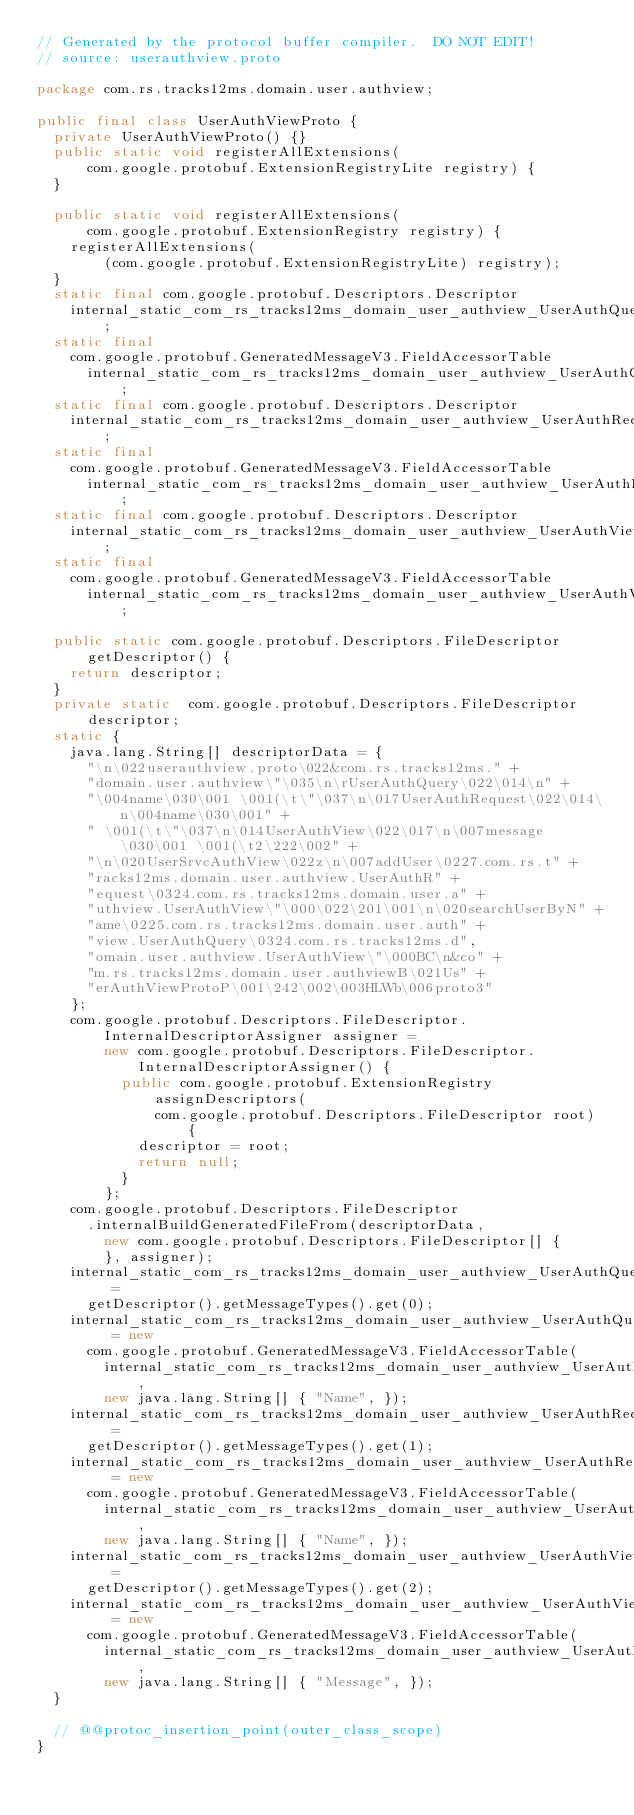<code> <loc_0><loc_0><loc_500><loc_500><_Java_>// Generated by the protocol buffer compiler.  DO NOT EDIT!
// source: userauthview.proto

package com.rs.tracks12ms.domain.user.authview;

public final class UserAuthViewProto {
  private UserAuthViewProto() {}
  public static void registerAllExtensions(
      com.google.protobuf.ExtensionRegistryLite registry) {
  }

  public static void registerAllExtensions(
      com.google.protobuf.ExtensionRegistry registry) {
    registerAllExtensions(
        (com.google.protobuf.ExtensionRegistryLite) registry);
  }
  static final com.google.protobuf.Descriptors.Descriptor
    internal_static_com_rs_tracks12ms_domain_user_authview_UserAuthQuery_descriptor;
  static final 
    com.google.protobuf.GeneratedMessageV3.FieldAccessorTable
      internal_static_com_rs_tracks12ms_domain_user_authview_UserAuthQuery_fieldAccessorTable;
  static final com.google.protobuf.Descriptors.Descriptor
    internal_static_com_rs_tracks12ms_domain_user_authview_UserAuthRequest_descriptor;
  static final 
    com.google.protobuf.GeneratedMessageV3.FieldAccessorTable
      internal_static_com_rs_tracks12ms_domain_user_authview_UserAuthRequest_fieldAccessorTable;
  static final com.google.protobuf.Descriptors.Descriptor
    internal_static_com_rs_tracks12ms_domain_user_authview_UserAuthView_descriptor;
  static final 
    com.google.protobuf.GeneratedMessageV3.FieldAccessorTable
      internal_static_com_rs_tracks12ms_domain_user_authview_UserAuthView_fieldAccessorTable;

  public static com.google.protobuf.Descriptors.FileDescriptor
      getDescriptor() {
    return descriptor;
  }
  private static  com.google.protobuf.Descriptors.FileDescriptor
      descriptor;
  static {
    java.lang.String[] descriptorData = {
      "\n\022userauthview.proto\022&com.rs.tracks12ms." +
      "domain.user.authview\"\035\n\rUserAuthQuery\022\014\n" +
      "\004name\030\001 \001(\t\"\037\n\017UserAuthRequest\022\014\n\004name\030\001" +
      " \001(\t\"\037\n\014UserAuthView\022\017\n\007message\030\001 \001(\t2\222\002" +
      "\n\020UserSrvcAuthView\022z\n\007addUser\0227.com.rs.t" +
      "racks12ms.domain.user.authview.UserAuthR" +
      "equest\0324.com.rs.tracks12ms.domain.user.a" +
      "uthview.UserAuthView\"\000\022\201\001\n\020searchUserByN" +
      "ame\0225.com.rs.tracks12ms.domain.user.auth" +
      "view.UserAuthQuery\0324.com.rs.tracks12ms.d",
      "omain.user.authview.UserAuthView\"\000BC\n&co" +
      "m.rs.tracks12ms.domain.user.authviewB\021Us" +
      "erAuthViewProtoP\001\242\002\003HLWb\006proto3"
    };
    com.google.protobuf.Descriptors.FileDescriptor.InternalDescriptorAssigner assigner =
        new com.google.protobuf.Descriptors.FileDescriptor.    InternalDescriptorAssigner() {
          public com.google.protobuf.ExtensionRegistry assignDescriptors(
              com.google.protobuf.Descriptors.FileDescriptor root) {
            descriptor = root;
            return null;
          }
        };
    com.google.protobuf.Descriptors.FileDescriptor
      .internalBuildGeneratedFileFrom(descriptorData,
        new com.google.protobuf.Descriptors.FileDescriptor[] {
        }, assigner);
    internal_static_com_rs_tracks12ms_domain_user_authview_UserAuthQuery_descriptor =
      getDescriptor().getMessageTypes().get(0);
    internal_static_com_rs_tracks12ms_domain_user_authview_UserAuthQuery_fieldAccessorTable = new
      com.google.protobuf.GeneratedMessageV3.FieldAccessorTable(
        internal_static_com_rs_tracks12ms_domain_user_authview_UserAuthQuery_descriptor,
        new java.lang.String[] { "Name", });
    internal_static_com_rs_tracks12ms_domain_user_authview_UserAuthRequest_descriptor =
      getDescriptor().getMessageTypes().get(1);
    internal_static_com_rs_tracks12ms_domain_user_authview_UserAuthRequest_fieldAccessorTable = new
      com.google.protobuf.GeneratedMessageV3.FieldAccessorTable(
        internal_static_com_rs_tracks12ms_domain_user_authview_UserAuthRequest_descriptor,
        new java.lang.String[] { "Name", });
    internal_static_com_rs_tracks12ms_domain_user_authview_UserAuthView_descriptor =
      getDescriptor().getMessageTypes().get(2);
    internal_static_com_rs_tracks12ms_domain_user_authview_UserAuthView_fieldAccessorTable = new
      com.google.protobuf.GeneratedMessageV3.FieldAccessorTable(
        internal_static_com_rs_tracks12ms_domain_user_authview_UserAuthView_descriptor,
        new java.lang.String[] { "Message", });
  }

  // @@protoc_insertion_point(outer_class_scope)
}
</code> 